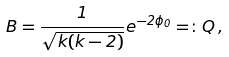<formula> <loc_0><loc_0><loc_500><loc_500>B = \frac { 1 } { \sqrt { k ( k - 2 ) } } e ^ { - 2 \phi _ { 0 } } = \colon Q \, ,</formula> 